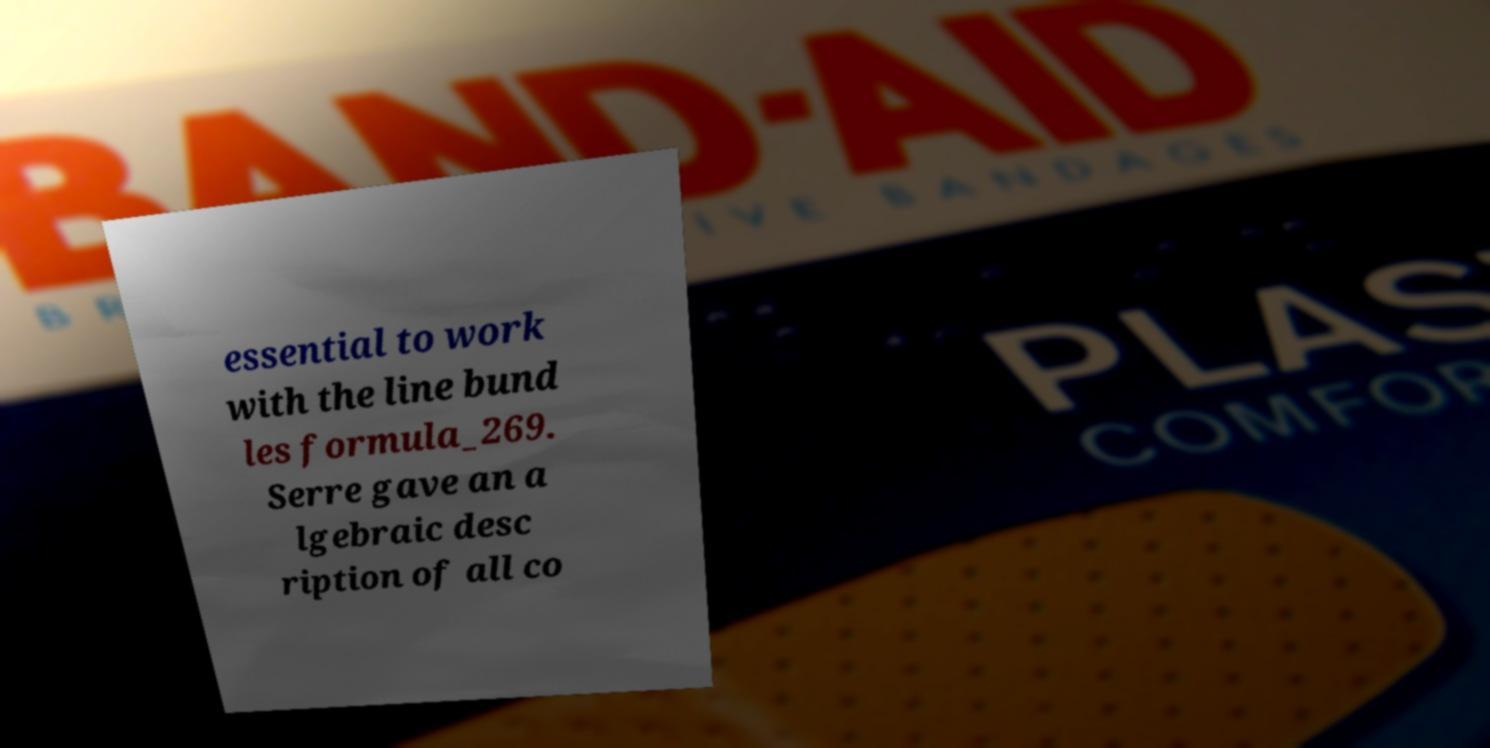Please read and relay the text visible in this image. What does it say? essential to work with the line bund les formula_269. Serre gave an a lgebraic desc ription of all co 